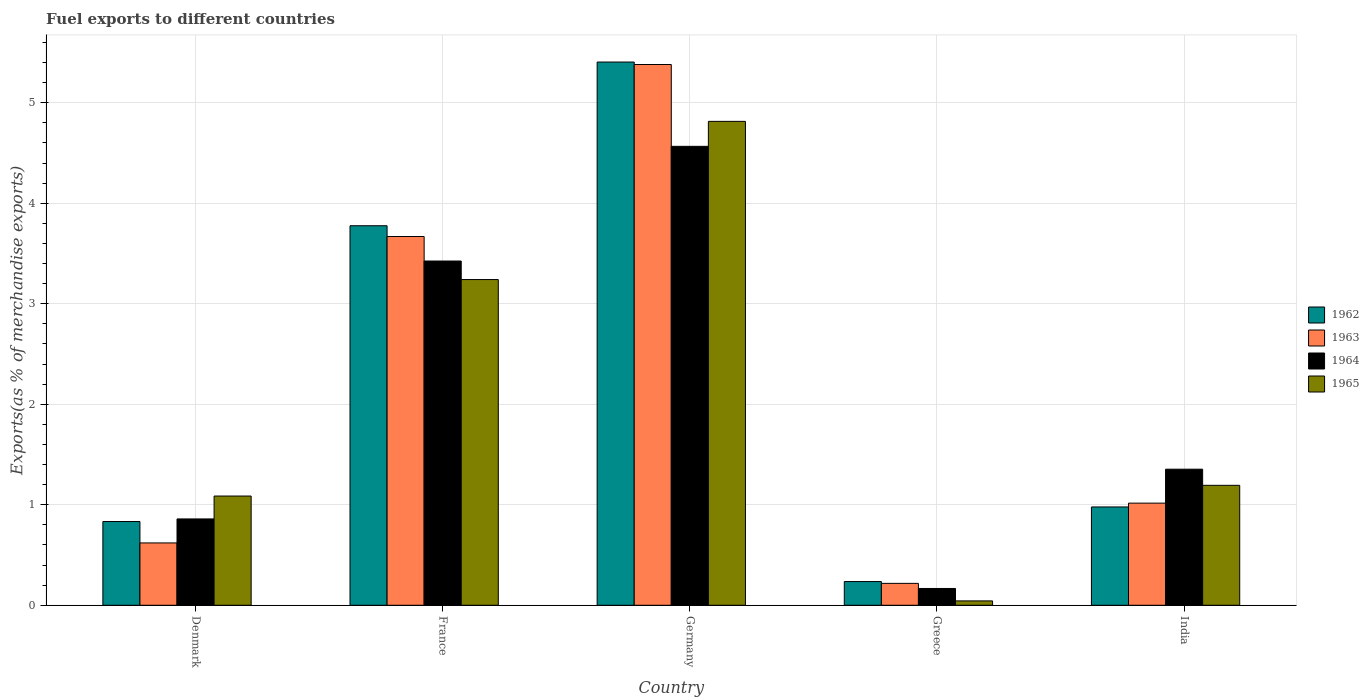How many different coloured bars are there?
Keep it short and to the point. 4. Are the number of bars per tick equal to the number of legend labels?
Keep it short and to the point. Yes. What is the label of the 1st group of bars from the left?
Offer a very short reply. Denmark. In how many cases, is the number of bars for a given country not equal to the number of legend labels?
Ensure brevity in your answer.  0. What is the percentage of exports to different countries in 1963 in Germany?
Keep it short and to the point. 5.38. Across all countries, what is the maximum percentage of exports to different countries in 1964?
Make the answer very short. 4.57. Across all countries, what is the minimum percentage of exports to different countries in 1963?
Offer a terse response. 0.22. In which country was the percentage of exports to different countries in 1965 minimum?
Offer a terse response. Greece. What is the total percentage of exports to different countries in 1964 in the graph?
Your answer should be very brief. 10.37. What is the difference between the percentage of exports to different countries in 1963 in Germany and that in India?
Your answer should be compact. 4.36. What is the difference between the percentage of exports to different countries in 1963 in Denmark and the percentage of exports to different countries in 1964 in Greece?
Ensure brevity in your answer.  0.45. What is the average percentage of exports to different countries in 1963 per country?
Give a very brief answer. 2.18. What is the difference between the percentage of exports to different countries of/in 1963 and percentage of exports to different countries of/in 1964 in Denmark?
Your answer should be compact. -0.24. What is the ratio of the percentage of exports to different countries in 1964 in Germany to that in Greece?
Offer a terse response. 27.34. Is the percentage of exports to different countries in 1962 in Germany less than that in India?
Keep it short and to the point. No. What is the difference between the highest and the second highest percentage of exports to different countries in 1965?
Make the answer very short. -2.05. What is the difference between the highest and the lowest percentage of exports to different countries in 1965?
Your response must be concise. 4.77. In how many countries, is the percentage of exports to different countries in 1964 greater than the average percentage of exports to different countries in 1964 taken over all countries?
Your answer should be very brief. 2. How many countries are there in the graph?
Provide a short and direct response. 5. What is the difference between two consecutive major ticks on the Y-axis?
Your answer should be compact. 1. Are the values on the major ticks of Y-axis written in scientific E-notation?
Offer a terse response. No. How many legend labels are there?
Make the answer very short. 4. How are the legend labels stacked?
Keep it short and to the point. Vertical. What is the title of the graph?
Provide a succinct answer. Fuel exports to different countries. Does "1988" appear as one of the legend labels in the graph?
Provide a short and direct response. No. What is the label or title of the Y-axis?
Offer a terse response. Exports(as % of merchandise exports). What is the Exports(as % of merchandise exports) in 1962 in Denmark?
Provide a succinct answer. 0.83. What is the Exports(as % of merchandise exports) in 1963 in Denmark?
Provide a short and direct response. 0.62. What is the Exports(as % of merchandise exports) in 1964 in Denmark?
Make the answer very short. 0.86. What is the Exports(as % of merchandise exports) in 1965 in Denmark?
Keep it short and to the point. 1.09. What is the Exports(as % of merchandise exports) in 1962 in France?
Give a very brief answer. 3.78. What is the Exports(as % of merchandise exports) of 1963 in France?
Offer a very short reply. 3.67. What is the Exports(as % of merchandise exports) of 1964 in France?
Your answer should be compact. 3.43. What is the Exports(as % of merchandise exports) of 1965 in France?
Keep it short and to the point. 3.24. What is the Exports(as % of merchandise exports) of 1962 in Germany?
Your answer should be very brief. 5.4. What is the Exports(as % of merchandise exports) in 1963 in Germany?
Your response must be concise. 5.38. What is the Exports(as % of merchandise exports) in 1964 in Germany?
Your answer should be compact. 4.57. What is the Exports(as % of merchandise exports) of 1965 in Germany?
Ensure brevity in your answer.  4.81. What is the Exports(as % of merchandise exports) of 1962 in Greece?
Offer a terse response. 0.24. What is the Exports(as % of merchandise exports) of 1963 in Greece?
Your answer should be compact. 0.22. What is the Exports(as % of merchandise exports) in 1964 in Greece?
Provide a succinct answer. 0.17. What is the Exports(as % of merchandise exports) of 1965 in Greece?
Your answer should be compact. 0.04. What is the Exports(as % of merchandise exports) in 1962 in India?
Make the answer very short. 0.98. What is the Exports(as % of merchandise exports) of 1963 in India?
Keep it short and to the point. 1.02. What is the Exports(as % of merchandise exports) in 1964 in India?
Offer a terse response. 1.35. What is the Exports(as % of merchandise exports) of 1965 in India?
Offer a very short reply. 1.19. Across all countries, what is the maximum Exports(as % of merchandise exports) of 1962?
Give a very brief answer. 5.4. Across all countries, what is the maximum Exports(as % of merchandise exports) in 1963?
Your answer should be very brief. 5.38. Across all countries, what is the maximum Exports(as % of merchandise exports) in 1964?
Offer a very short reply. 4.57. Across all countries, what is the maximum Exports(as % of merchandise exports) of 1965?
Keep it short and to the point. 4.81. Across all countries, what is the minimum Exports(as % of merchandise exports) in 1962?
Ensure brevity in your answer.  0.24. Across all countries, what is the minimum Exports(as % of merchandise exports) in 1963?
Offer a very short reply. 0.22. Across all countries, what is the minimum Exports(as % of merchandise exports) of 1964?
Your answer should be very brief. 0.17. Across all countries, what is the minimum Exports(as % of merchandise exports) of 1965?
Ensure brevity in your answer.  0.04. What is the total Exports(as % of merchandise exports) of 1962 in the graph?
Provide a succinct answer. 11.23. What is the total Exports(as % of merchandise exports) in 1963 in the graph?
Offer a very short reply. 10.9. What is the total Exports(as % of merchandise exports) in 1964 in the graph?
Your answer should be compact. 10.37. What is the total Exports(as % of merchandise exports) of 1965 in the graph?
Your answer should be compact. 10.38. What is the difference between the Exports(as % of merchandise exports) in 1962 in Denmark and that in France?
Provide a short and direct response. -2.94. What is the difference between the Exports(as % of merchandise exports) in 1963 in Denmark and that in France?
Ensure brevity in your answer.  -3.05. What is the difference between the Exports(as % of merchandise exports) of 1964 in Denmark and that in France?
Give a very brief answer. -2.57. What is the difference between the Exports(as % of merchandise exports) of 1965 in Denmark and that in France?
Offer a terse response. -2.15. What is the difference between the Exports(as % of merchandise exports) of 1962 in Denmark and that in Germany?
Keep it short and to the point. -4.57. What is the difference between the Exports(as % of merchandise exports) of 1963 in Denmark and that in Germany?
Your answer should be very brief. -4.76. What is the difference between the Exports(as % of merchandise exports) in 1964 in Denmark and that in Germany?
Make the answer very short. -3.71. What is the difference between the Exports(as % of merchandise exports) of 1965 in Denmark and that in Germany?
Your response must be concise. -3.73. What is the difference between the Exports(as % of merchandise exports) of 1962 in Denmark and that in Greece?
Offer a very short reply. 0.6. What is the difference between the Exports(as % of merchandise exports) in 1963 in Denmark and that in Greece?
Keep it short and to the point. 0.4. What is the difference between the Exports(as % of merchandise exports) of 1964 in Denmark and that in Greece?
Keep it short and to the point. 0.69. What is the difference between the Exports(as % of merchandise exports) in 1965 in Denmark and that in Greece?
Your response must be concise. 1.04. What is the difference between the Exports(as % of merchandise exports) in 1962 in Denmark and that in India?
Give a very brief answer. -0.14. What is the difference between the Exports(as % of merchandise exports) in 1963 in Denmark and that in India?
Give a very brief answer. -0.4. What is the difference between the Exports(as % of merchandise exports) of 1964 in Denmark and that in India?
Provide a succinct answer. -0.49. What is the difference between the Exports(as % of merchandise exports) of 1965 in Denmark and that in India?
Keep it short and to the point. -0.11. What is the difference between the Exports(as % of merchandise exports) of 1962 in France and that in Germany?
Keep it short and to the point. -1.63. What is the difference between the Exports(as % of merchandise exports) of 1963 in France and that in Germany?
Your answer should be very brief. -1.71. What is the difference between the Exports(as % of merchandise exports) in 1964 in France and that in Germany?
Your response must be concise. -1.14. What is the difference between the Exports(as % of merchandise exports) of 1965 in France and that in Germany?
Offer a terse response. -1.57. What is the difference between the Exports(as % of merchandise exports) in 1962 in France and that in Greece?
Make the answer very short. 3.54. What is the difference between the Exports(as % of merchandise exports) of 1963 in France and that in Greece?
Provide a succinct answer. 3.45. What is the difference between the Exports(as % of merchandise exports) in 1964 in France and that in Greece?
Offer a very short reply. 3.26. What is the difference between the Exports(as % of merchandise exports) of 1965 in France and that in Greece?
Offer a very short reply. 3.2. What is the difference between the Exports(as % of merchandise exports) of 1962 in France and that in India?
Your response must be concise. 2.8. What is the difference between the Exports(as % of merchandise exports) in 1963 in France and that in India?
Offer a terse response. 2.65. What is the difference between the Exports(as % of merchandise exports) in 1964 in France and that in India?
Your answer should be very brief. 2.07. What is the difference between the Exports(as % of merchandise exports) in 1965 in France and that in India?
Ensure brevity in your answer.  2.05. What is the difference between the Exports(as % of merchandise exports) in 1962 in Germany and that in Greece?
Your answer should be very brief. 5.17. What is the difference between the Exports(as % of merchandise exports) of 1963 in Germany and that in Greece?
Ensure brevity in your answer.  5.16. What is the difference between the Exports(as % of merchandise exports) in 1964 in Germany and that in Greece?
Your response must be concise. 4.4. What is the difference between the Exports(as % of merchandise exports) of 1965 in Germany and that in Greece?
Your answer should be very brief. 4.77. What is the difference between the Exports(as % of merchandise exports) in 1962 in Germany and that in India?
Offer a very short reply. 4.43. What is the difference between the Exports(as % of merchandise exports) in 1963 in Germany and that in India?
Your answer should be very brief. 4.36. What is the difference between the Exports(as % of merchandise exports) in 1964 in Germany and that in India?
Your answer should be compact. 3.21. What is the difference between the Exports(as % of merchandise exports) of 1965 in Germany and that in India?
Offer a very short reply. 3.62. What is the difference between the Exports(as % of merchandise exports) in 1962 in Greece and that in India?
Make the answer very short. -0.74. What is the difference between the Exports(as % of merchandise exports) of 1963 in Greece and that in India?
Provide a short and direct response. -0.8. What is the difference between the Exports(as % of merchandise exports) in 1964 in Greece and that in India?
Make the answer very short. -1.19. What is the difference between the Exports(as % of merchandise exports) of 1965 in Greece and that in India?
Your response must be concise. -1.15. What is the difference between the Exports(as % of merchandise exports) of 1962 in Denmark and the Exports(as % of merchandise exports) of 1963 in France?
Make the answer very short. -2.84. What is the difference between the Exports(as % of merchandise exports) of 1962 in Denmark and the Exports(as % of merchandise exports) of 1964 in France?
Your response must be concise. -2.59. What is the difference between the Exports(as % of merchandise exports) of 1962 in Denmark and the Exports(as % of merchandise exports) of 1965 in France?
Keep it short and to the point. -2.41. What is the difference between the Exports(as % of merchandise exports) in 1963 in Denmark and the Exports(as % of merchandise exports) in 1964 in France?
Make the answer very short. -2.8. What is the difference between the Exports(as % of merchandise exports) in 1963 in Denmark and the Exports(as % of merchandise exports) in 1965 in France?
Keep it short and to the point. -2.62. What is the difference between the Exports(as % of merchandise exports) in 1964 in Denmark and the Exports(as % of merchandise exports) in 1965 in France?
Keep it short and to the point. -2.38. What is the difference between the Exports(as % of merchandise exports) in 1962 in Denmark and the Exports(as % of merchandise exports) in 1963 in Germany?
Make the answer very short. -4.55. What is the difference between the Exports(as % of merchandise exports) of 1962 in Denmark and the Exports(as % of merchandise exports) of 1964 in Germany?
Ensure brevity in your answer.  -3.73. What is the difference between the Exports(as % of merchandise exports) of 1962 in Denmark and the Exports(as % of merchandise exports) of 1965 in Germany?
Your response must be concise. -3.98. What is the difference between the Exports(as % of merchandise exports) of 1963 in Denmark and the Exports(as % of merchandise exports) of 1964 in Germany?
Ensure brevity in your answer.  -3.95. What is the difference between the Exports(as % of merchandise exports) in 1963 in Denmark and the Exports(as % of merchandise exports) in 1965 in Germany?
Your answer should be compact. -4.19. What is the difference between the Exports(as % of merchandise exports) of 1964 in Denmark and the Exports(as % of merchandise exports) of 1965 in Germany?
Provide a short and direct response. -3.96. What is the difference between the Exports(as % of merchandise exports) in 1962 in Denmark and the Exports(as % of merchandise exports) in 1963 in Greece?
Your answer should be very brief. 0.62. What is the difference between the Exports(as % of merchandise exports) in 1962 in Denmark and the Exports(as % of merchandise exports) in 1964 in Greece?
Keep it short and to the point. 0.67. What is the difference between the Exports(as % of merchandise exports) of 1962 in Denmark and the Exports(as % of merchandise exports) of 1965 in Greece?
Your answer should be compact. 0.79. What is the difference between the Exports(as % of merchandise exports) in 1963 in Denmark and the Exports(as % of merchandise exports) in 1964 in Greece?
Your response must be concise. 0.45. What is the difference between the Exports(as % of merchandise exports) of 1963 in Denmark and the Exports(as % of merchandise exports) of 1965 in Greece?
Your answer should be very brief. 0.58. What is the difference between the Exports(as % of merchandise exports) in 1964 in Denmark and the Exports(as % of merchandise exports) in 1965 in Greece?
Ensure brevity in your answer.  0.82. What is the difference between the Exports(as % of merchandise exports) of 1962 in Denmark and the Exports(as % of merchandise exports) of 1963 in India?
Offer a very short reply. -0.18. What is the difference between the Exports(as % of merchandise exports) of 1962 in Denmark and the Exports(as % of merchandise exports) of 1964 in India?
Your answer should be very brief. -0.52. What is the difference between the Exports(as % of merchandise exports) in 1962 in Denmark and the Exports(as % of merchandise exports) in 1965 in India?
Your answer should be compact. -0.36. What is the difference between the Exports(as % of merchandise exports) of 1963 in Denmark and the Exports(as % of merchandise exports) of 1964 in India?
Provide a succinct answer. -0.73. What is the difference between the Exports(as % of merchandise exports) in 1963 in Denmark and the Exports(as % of merchandise exports) in 1965 in India?
Make the answer very short. -0.57. What is the difference between the Exports(as % of merchandise exports) of 1964 in Denmark and the Exports(as % of merchandise exports) of 1965 in India?
Make the answer very short. -0.33. What is the difference between the Exports(as % of merchandise exports) in 1962 in France and the Exports(as % of merchandise exports) in 1963 in Germany?
Your answer should be compact. -1.6. What is the difference between the Exports(as % of merchandise exports) in 1962 in France and the Exports(as % of merchandise exports) in 1964 in Germany?
Provide a succinct answer. -0.79. What is the difference between the Exports(as % of merchandise exports) in 1962 in France and the Exports(as % of merchandise exports) in 1965 in Germany?
Ensure brevity in your answer.  -1.04. What is the difference between the Exports(as % of merchandise exports) of 1963 in France and the Exports(as % of merchandise exports) of 1964 in Germany?
Your answer should be compact. -0.9. What is the difference between the Exports(as % of merchandise exports) in 1963 in France and the Exports(as % of merchandise exports) in 1965 in Germany?
Make the answer very short. -1.15. What is the difference between the Exports(as % of merchandise exports) of 1964 in France and the Exports(as % of merchandise exports) of 1965 in Germany?
Provide a short and direct response. -1.39. What is the difference between the Exports(as % of merchandise exports) of 1962 in France and the Exports(as % of merchandise exports) of 1963 in Greece?
Your answer should be compact. 3.56. What is the difference between the Exports(as % of merchandise exports) in 1962 in France and the Exports(as % of merchandise exports) in 1964 in Greece?
Your answer should be very brief. 3.61. What is the difference between the Exports(as % of merchandise exports) of 1962 in France and the Exports(as % of merchandise exports) of 1965 in Greece?
Ensure brevity in your answer.  3.73. What is the difference between the Exports(as % of merchandise exports) of 1963 in France and the Exports(as % of merchandise exports) of 1964 in Greece?
Keep it short and to the point. 3.5. What is the difference between the Exports(as % of merchandise exports) of 1963 in France and the Exports(as % of merchandise exports) of 1965 in Greece?
Your answer should be very brief. 3.63. What is the difference between the Exports(as % of merchandise exports) in 1964 in France and the Exports(as % of merchandise exports) in 1965 in Greece?
Provide a succinct answer. 3.38. What is the difference between the Exports(as % of merchandise exports) of 1962 in France and the Exports(as % of merchandise exports) of 1963 in India?
Offer a terse response. 2.76. What is the difference between the Exports(as % of merchandise exports) of 1962 in France and the Exports(as % of merchandise exports) of 1964 in India?
Keep it short and to the point. 2.42. What is the difference between the Exports(as % of merchandise exports) in 1962 in France and the Exports(as % of merchandise exports) in 1965 in India?
Your answer should be compact. 2.58. What is the difference between the Exports(as % of merchandise exports) of 1963 in France and the Exports(as % of merchandise exports) of 1964 in India?
Your response must be concise. 2.32. What is the difference between the Exports(as % of merchandise exports) in 1963 in France and the Exports(as % of merchandise exports) in 1965 in India?
Offer a very short reply. 2.48. What is the difference between the Exports(as % of merchandise exports) of 1964 in France and the Exports(as % of merchandise exports) of 1965 in India?
Offer a very short reply. 2.23. What is the difference between the Exports(as % of merchandise exports) of 1962 in Germany and the Exports(as % of merchandise exports) of 1963 in Greece?
Your answer should be compact. 5.19. What is the difference between the Exports(as % of merchandise exports) of 1962 in Germany and the Exports(as % of merchandise exports) of 1964 in Greece?
Provide a succinct answer. 5.24. What is the difference between the Exports(as % of merchandise exports) of 1962 in Germany and the Exports(as % of merchandise exports) of 1965 in Greece?
Offer a terse response. 5.36. What is the difference between the Exports(as % of merchandise exports) in 1963 in Germany and the Exports(as % of merchandise exports) in 1964 in Greece?
Your answer should be compact. 5.21. What is the difference between the Exports(as % of merchandise exports) in 1963 in Germany and the Exports(as % of merchandise exports) in 1965 in Greece?
Offer a very short reply. 5.34. What is the difference between the Exports(as % of merchandise exports) of 1964 in Germany and the Exports(as % of merchandise exports) of 1965 in Greece?
Offer a terse response. 4.52. What is the difference between the Exports(as % of merchandise exports) of 1962 in Germany and the Exports(as % of merchandise exports) of 1963 in India?
Provide a succinct answer. 4.39. What is the difference between the Exports(as % of merchandise exports) of 1962 in Germany and the Exports(as % of merchandise exports) of 1964 in India?
Keep it short and to the point. 4.05. What is the difference between the Exports(as % of merchandise exports) in 1962 in Germany and the Exports(as % of merchandise exports) in 1965 in India?
Provide a short and direct response. 4.21. What is the difference between the Exports(as % of merchandise exports) of 1963 in Germany and the Exports(as % of merchandise exports) of 1964 in India?
Provide a short and direct response. 4.03. What is the difference between the Exports(as % of merchandise exports) of 1963 in Germany and the Exports(as % of merchandise exports) of 1965 in India?
Offer a terse response. 4.19. What is the difference between the Exports(as % of merchandise exports) in 1964 in Germany and the Exports(as % of merchandise exports) in 1965 in India?
Provide a short and direct response. 3.37. What is the difference between the Exports(as % of merchandise exports) in 1962 in Greece and the Exports(as % of merchandise exports) in 1963 in India?
Provide a short and direct response. -0.78. What is the difference between the Exports(as % of merchandise exports) of 1962 in Greece and the Exports(as % of merchandise exports) of 1964 in India?
Give a very brief answer. -1.12. What is the difference between the Exports(as % of merchandise exports) in 1962 in Greece and the Exports(as % of merchandise exports) in 1965 in India?
Provide a succinct answer. -0.96. What is the difference between the Exports(as % of merchandise exports) of 1963 in Greece and the Exports(as % of merchandise exports) of 1964 in India?
Ensure brevity in your answer.  -1.14. What is the difference between the Exports(as % of merchandise exports) in 1963 in Greece and the Exports(as % of merchandise exports) in 1965 in India?
Your answer should be very brief. -0.98. What is the difference between the Exports(as % of merchandise exports) in 1964 in Greece and the Exports(as % of merchandise exports) in 1965 in India?
Your answer should be compact. -1.03. What is the average Exports(as % of merchandise exports) of 1962 per country?
Your answer should be very brief. 2.25. What is the average Exports(as % of merchandise exports) of 1963 per country?
Your answer should be very brief. 2.18. What is the average Exports(as % of merchandise exports) of 1964 per country?
Ensure brevity in your answer.  2.07. What is the average Exports(as % of merchandise exports) of 1965 per country?
Your answer should be compact. 2.08. What is the difference between the Exports(as % of merchandise exports) in 1962 and Exports(as % of merchandise exports) in 1963 in Denmark?
Keep it short and to the point. 0.21. What is the difference between the Exports(as % of merchandise exports) of 1962 and Exports(as % of merchandise exports) of 1964 in Denmark?
Make the answer very short. -0.03. What is the difference between the Exports(as % of merchandise exports) in 1962 and Exports(as % of merchandise exports) in 1965 in Denmark?
Offer a terse response. -0.25. What is the difference between the Exports(as % of merchandise exports) in 1963 and Exports(as % of merchandise exports) in 1964 in Denmark?
Offer a very short reply. -0.24. What is the difference between the Exports(as % of merchandise exports) of 1963 and Exports(as % of merchandise exports) of 1965 in Denmark?
Keep it short and to the point. -0.47. What is the difference between the Exports(as % of merchandise exports) in 1964 and Exports(as % of merchandise exports) in 1965 in Denmark?
Your answer should be compact. -0.23. What is the difference between the Exports(as % of merchandise exports) of 1962 and Exports(as % of merchandise exports) of 1963 in France?
Offer a terse response. 0.11. What is the difference between the Exports(as % of merchandise exports) of 1962 and Exports(as % of merchandise exports) of 1964 in France?
Give a very brief answer. 0.35. What is the difference between the Exports(as % of merchandise exports) of 1962 and Exports(as % of merchandise exports) of 1965 in France?
Provide a succinct answer. 0.54. What is the difference between the Exports(as % of merchandise exports) of 1963 and Exports(as % of merchandise exports) of 1964 in France?
Your answer should be very brief. 0.24. What is the difference between the Exports(as % of merchandise exports) of 1963 and Exports(as % of merchandise exports) of 1965 in France?
Offer a very short reply. 0.43. What is the difference between the Exports(as % of merchandise exports) of 1964 and Exports(as % of merchandise exports) of 1965 in France?
Your answer should be very brief. 0.18. What is the difference between the Exports(as % of merchandise exports) of 1962 and Exports(as % of merchandise exports) of 1963 in Germany?
Ensure brevity in your answer.  0.02. What is the difference between the Exports(as % of merchandise exports) of 1962 and Exports(as % of merchandise exports) of 1964 in Germany?
Provide a short and direct response. 0.84. What is the difference between the Exports(as % of merchandise exports) in 1962 and Exports(as % of merchandise exports) in 1965 in Germany?
Your answer should be very brief. 0.59. What is the difference between the Exports(as % of merchandise exports) of 1963 and Exports(as % of merchandise exports) of 1964 in Germany?
Give a very brief answer. 0.81. What is the difference between the Exports(as % of merchandise exports) of 1963 and Exports(as % of merchandise exports) of 1965 in Germany?
Offer a very short reply. 0.57. What is the difference between the Exports(as % of merchandise exports) in 1964 and Exports(as % of merchandise exports) in 1965 in Germany?
Provide a succinct answer. -0.25. What is the difference between the Exports(as % of merchandise exports) in 1962 and Exports(as % of merchandise exports) in 1963 in Greece?
Give a very brief answer. 0.02. What is the difference between the Exports(as % of merchandise exports) in 1962 and Exports(as % of merchandise exports) in 1964 in Greece?
Your response must be concise. 0.07. What is the difference between the Exports(as % of merchandise exports) in 1962 and Exports(as % of merchandise exports) in 1965 in Greece?
Your answer should be compact. 0.19. What is the difference between the Exports(as % of merchandise exports) in 1963 and Exports(as % of merchandise exports) in 1964 in Greece?
Offer a very short reply. 0.05. What is the difference between the Exports(as % of merchandise exports) of 1963 and Exports(as % of merchandise exports) of 1965 in Greece?
Your answer should be very brief. 0.17. What is the difference between the Exports(as % of merchandise exports) in 1964 and Exports(as % of merchandise exports) in 1965 in Greece?
Give a very brief answer. 0.12. What is the difference between the Exports(as % of merchandise exports) in 1962 and Exports(as % of merchandise exports) in 1963 in India?
Your answer should be very brief. -0.04. What is the difference between the Exports(as % of merchandise exports) of 1962 and Exports(as % of merchandise exports) of 1964 in India?
Provide a succinct answer. -0.38. What is the difference between the Exports(as % of merchandise exports) in 1962 and Exports(as % of merchandise exports) in 1965 in India?
Your response must be concise. -0.22. What is the difference between the Exports(as % of merchandise exports) of 1963 and Exports(as % of merchandise exports) of 1964 in India?
Provide a succinct answer. -0.34. What is the difference between the Exports(as % of merchandise exports) of 1963 and Exports(as % of merchandise exports) of 1965 in India?
Offer a terse response. -0.18. What is the difference between the Exports(as % of merchandise exports) in 1964 and Exports(as % of merchandise exports) in 1965 in India?
Ensure brevity in your answer.  0.16. What is the ratio of the Exports(as % of merchandise exports) of 1962 in Denmark to that in France?
Your answer should be very brief. 0.22. What is the ratio of the Exports(as % of merchandise exports) of 1963 in Denmark to that in France?
Make the answer very short. 0.17. What is the ratio of the Exports(as % of merchandise exports) of 1964 in Denmark to that in France?
Offer a very short reply. 0.25. What is the ratio of the Exports(as % of merchandise exports) of 1965 in Denmark to that in France?
Ensure brevity in your answer.  0.34. What is the ratio of the Exports(as % of merchandise exports) in 1962 in Denmark to that in Germany?
Keep it short and to the point. 0.15. What is the ratio of the Exports(as % of merchandise exports) of 1963 in Denmark to that in Germany?
Make the answer very short. 0.12. What is the ratio of the Exports(as % of merchandise exports) in 1964 in Denmark to that in Germany?
Provide a succinct answer. 0.19. What is the ratio of the Exports(as % of merchandise exports) of 1965 in Denmark to that in Germany?
Provide a succinct answer. 0.23. What is the ratio of the Exports(as % of merchandise exports) of 1962 in Denmark to that in Greece?
Give a very brief answer. 3.53. What is the ratio of the Exports(as % of merchandise exports) in 1963 in Denmark to that in Greece?
Make the answer very short. 2.85. What is the ratio of the Exports(as % of merchandise exports) in 1964 in Denmark to that in Greece?
Your answer should be very brief. 5.14. What is the ratio of the Exports(as % of merchandise exports) of 1965 in Denmark to that in Greece?
Your answer should be compact. 25.05. What is the ratio of the Exports(as % of merchandise exports) in 1962 in Denmark to that in India?
Your answer should be very brief. 0.85. What is the ratio of the Exports(as % of merchandise exports) of 1963 in Denmark to that in India?
Offer a very short reply. 0.61. What is the ratio of the Exports(as % of merchandise exports) in 1964 in Denmark to that in India?
Your answer should be compact. 0.63. What is the ratio of the Exports(as % of merchandise exports) in 1965 in Denmark to that in India?
Provide a short and direct response. 0.91. What is the ratio of the Exports(as % of merchandise exports) of 1962 in France to that in Germany?
Your answer should be compact. 0.7. What is the ratio of the Exports(as % of merchandise exports) of 1963 in France to that in Germany?
Provide a succinct answer. 0.68. What is the ratio of the Exports(as % of merchandise exports) of 1964 in France to that in Germany?
Give a very brief answer. 0.75. What is the ratio of the Exports(as % of merchandise exports) of 1965 in France to that in Germany?
Your answer should be compact. 0.67. What is the ratio of the Exports(as % of merchandise exports) in 1962 in France to that in Greece?
Keep it short and to the point. 16.01. What is the ratio of the Exports(as % of merchandise exports) of 1963 in France to that in Greece?
Provide a succinct answer. 16.85. What is the ratio of the Exports(as % of merchandise exports) of 1964 in France to that in Greece?
Your response must be concise. 20.5. What is the ratio of the Exports(as % of merchandise exports) in 1965 in France to that in Greece?
Offer a very short reply. 74.69. What is the ratio of the Exports(as % of merchandise exports) of 1962 in France to that in India?
Offer a very short reply. 3.86. What is the ratio of the Exports(as % of merchandise exports) in 1963 in France to that in India?
Keep it short and to the point. 3.61. What is the ratio of the Exports(as % of merchandise exports) in 1964 in France to that in India?
Offer a terse response. 2.53. What is the ratio of the Exports(as % of merchandise exports) of 1965 in France to that in India?
Offer a terse response. 2.72. What is the ratio of the Exports(as % of merchandise exports) in 1962 in Germany to that in Greece?
Provide a succinct answer. 22.91. What is the ratio of the Exports(as % of merchandise exports) in 1963 in Germany to that in Greece?
Provide a succinct answer. 24.71. What is the ratio of the Exports(as % of merchandise exports) of 1964 in Germany to that in Greece?
Your answer should be very brief. 27.34. What is the ratio of the Exports(as % of merchandise exports) in 1965 in Germany to that in Greece?
Keep it short and to the point. 110.96. What is the ratio of the Exports(as % of merchandise exports) of 1962 in Germany to that in India?
Give a very brief answer. 5.53. What is the ratio of the Exports(as % of merchandise exports) in 1963 in Germany to that in India?
Offer a very short reply. 5.3. What is the ratio of the Exports(as % of merchandise exports) of 1964 in Germany to that in India?
Keep it short and to the point. 3.37. What is the ratio of the Exports(as % of merchandise exports) of 1965 in Germany to that in India?
Keep it short and to the point. 4.03. What is the ratio of the Exports(as % of merchandise exports) of 1962 in Greece to that in India?
Make the answer very short. 0.24. What is the ratio of the Exports(as % of merchandise exports) in 1963 in Greece to that in India?
Provide a succinct answer. 0.21. What is the ratio of the Exports(as % of merchandise exports) of 1964 in Greece to that in India?
Offer a very short reply. 0.12. What is the ratio of the Exports(as % of merchandise exports) in 1965 in Greece to that in India?
Provide a short and direct response. 0.04. What is the difference between the highest and the second highest Exports(as % of merchandise exports) in 1962?
Provide a short and direct response. 1.63. What is the difference between the highest and the second highest Exports(as % of merchandise exports) in 1963?
Provide a succinct answer. 1.71. What is the difference between the highest and the second highest Exports(as % of merchandise exports) of 1964?
Your answer should be very brief. 1.14. What is the difference between the highest and the second highest Exports(as % of merchandise exports) in 1965?
Offer a very short reply. 1.57. What is the difference between the highest and the lowest Exports(as % of merchandise exports) of 1962?
Your response must be concise. 5.17. What is the difference between the highest and the lowest Exports(as % of merchandise exports) of 1963?
Provide a succinct answer. 5.16. What is the difference between the highest and the lowest Exports(as % of merchandise exports) in 1964?
Offer a terse response. 4.4. What is the difference between the highest and the lowest Exports(as % of merchandise exports) in 1965?
Offer a terse response. 4.77. 